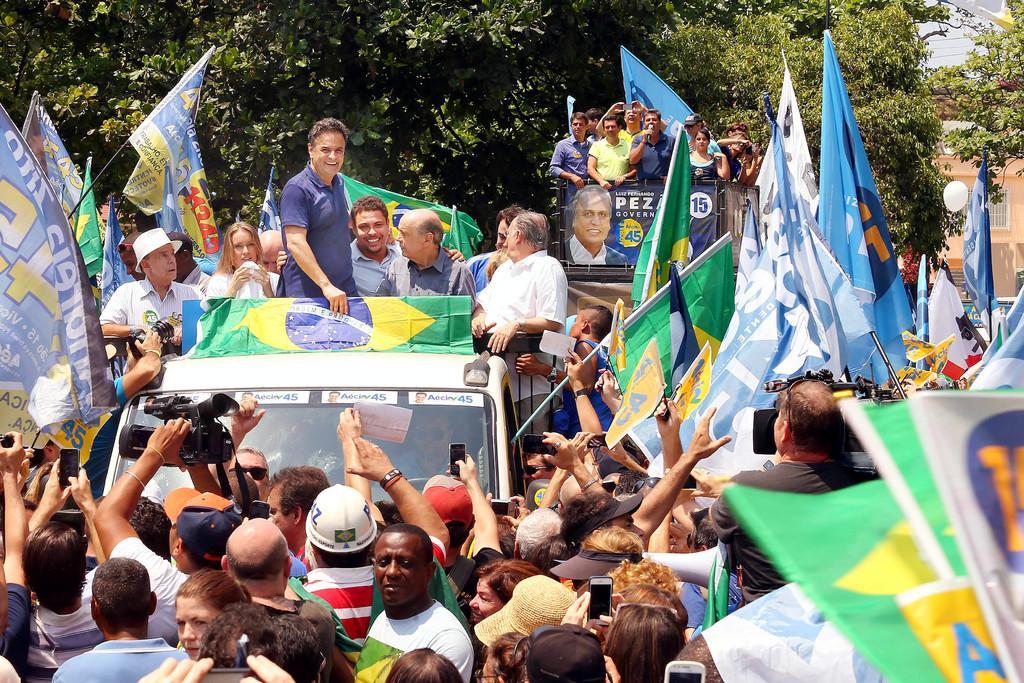Could you give a brief overview of what you see in this image? In this image, we can see a group of people. Few are holding camera and flags. Here we can see vehicles. Few people are standing on the vehicle. Background we can see trees, banner, house, wall, window. 